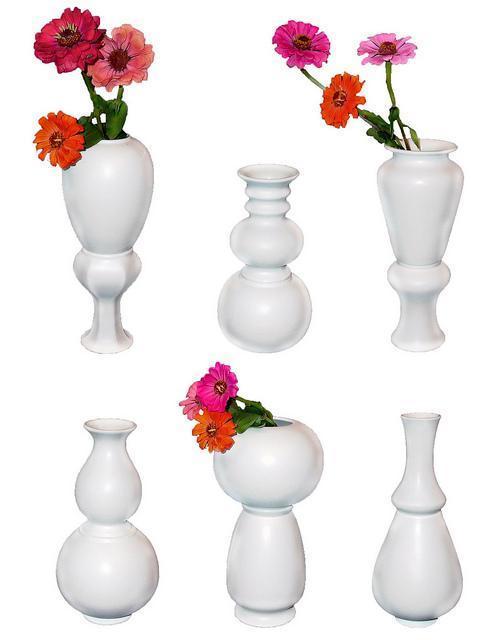How many different vases are there?
Give a very brief answer. 6. How many vases are there?
Give a very brief answer. 6. How many watches is this man wearing?
Give a very brief answer. 0. 